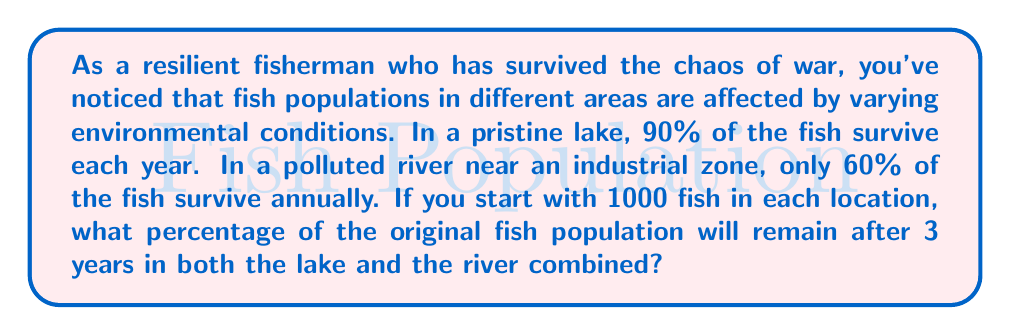Can you solve this math problem? Let's approach this step-by-step:

1) For the pristine lake:
   - Survival rate per year: 90% or 0.90
   - Initial population: 1000 fish
   - After 3 years: $1000 \times (0.90)^3 = 1000 \times 0.729 = 729$ fish

2) For the polluted river:
   - Survival rate per year: 60% or 0.60
   - Initial population: 1000 fish
   - After 3 years: $1000 \times (0.60)^3 = 1000 \times 0.216 = 216$ fish

3) Total surviving fish after 3 years:
   $729 + 216 = 945$ fish

4) Original total population:
   $1000 + 1000 = 2000$ fish

5) Percentage of original population remaining:
   $$\text{Percentage} = \frac{\text{Surviving fish}}{\text{Original population}} \times 100\%$$
   $$= \frac{945}{2000} \times 100\% = 0.4725 \times 100\% = 47.25\%$$

Therefore, 47.25% of the original fish population will remain after 3 years in both locations combined.
Answer: 47.25% 